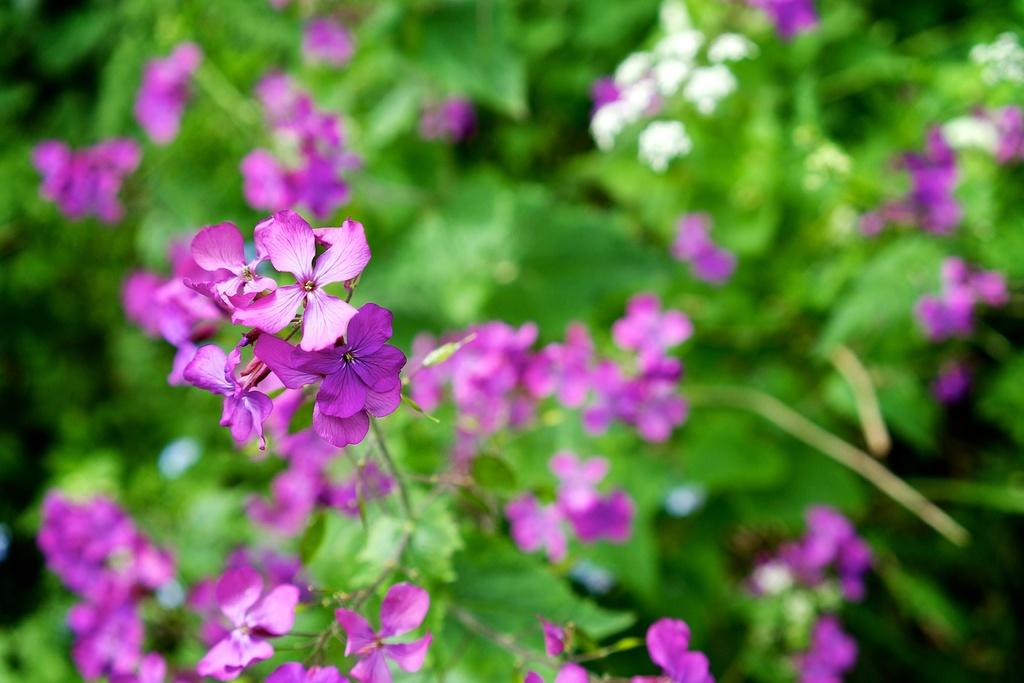What is the main subject of the image? The main subject of the image is a zoomed-in picture of flowers. Where are the flowers located in the image? The flowers are on the left side of the image. What type of sand can be seen in the image? There is no sand present in the image; it features a zoomed-in picture of flowers. How does the image turn into a different scene? The image does not turn into a different scene; it remains a zoomed-in picture of flowers. 